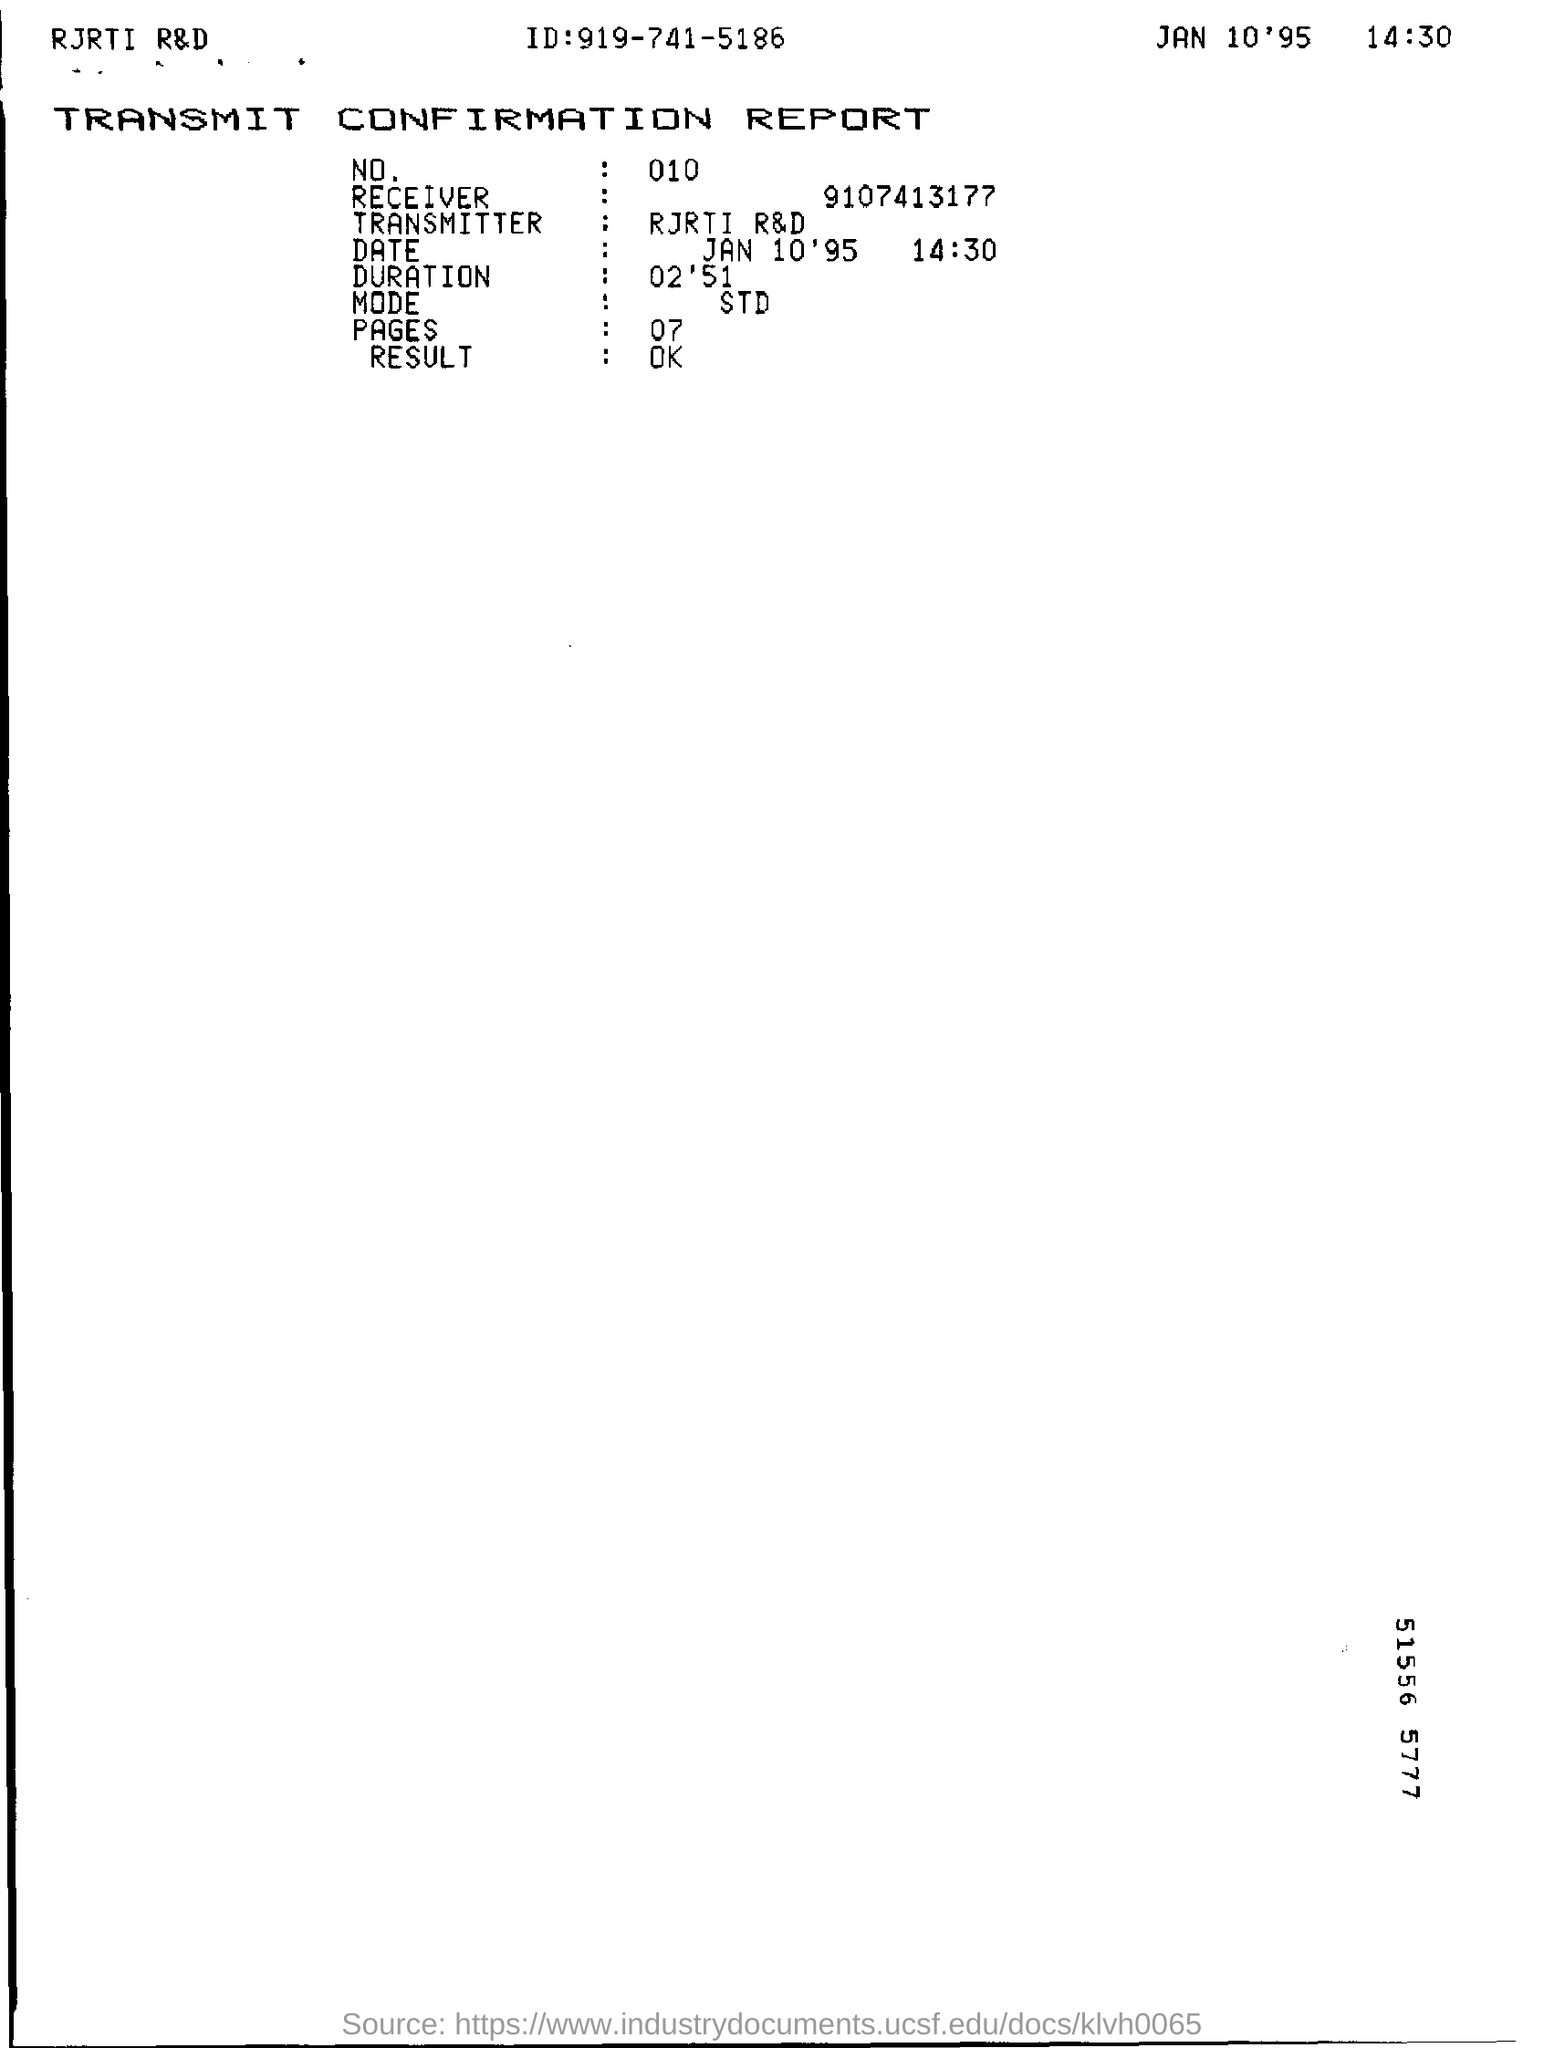Highlight a few significant elements in this photo. The date and time mentioned in the report is January 10, 1995 at 2:30 PM. The ID mentioned in the report is 919-741-5186. The report mentions 07 pages. The report mentions "NO" with a value of 010. The duration, as per the report, is 2 minutes and 51 seconds. 